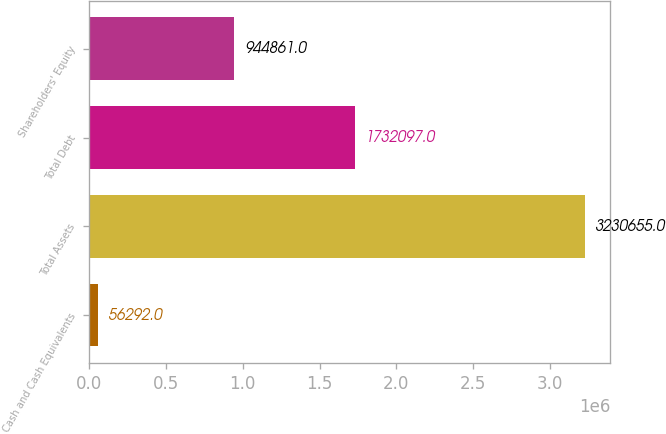<chart> <loc_0><loc_0><loc_500><loc_500><bar_chart><fcel>Cash and Cash Equivalents<fcel>Total Assets<fcel>Total Debt<fcel>Shareholders' Equity<nl><fcel>56292<fcel>3.23066e+06<fcel>1.7321e+06<fcel>944861<nl></chart> 